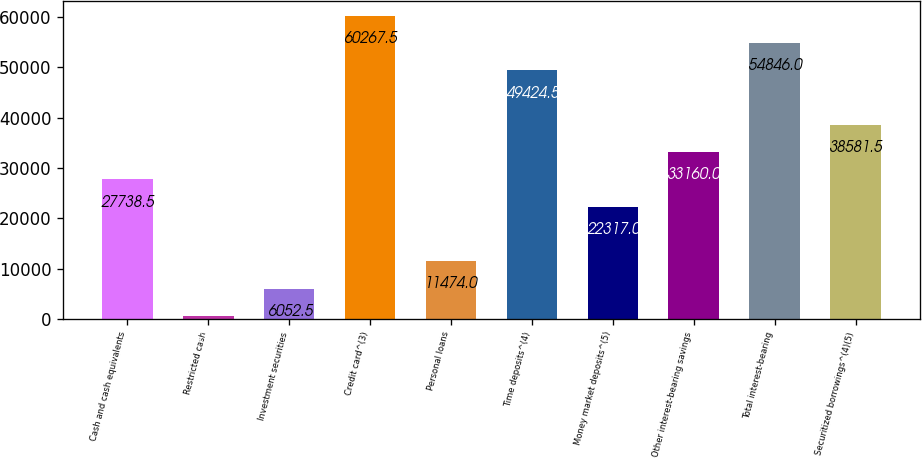Convert chart. <chart><loc_0><loc_0><loc_500><loc_500><bar_chart><fcel>Cash and cash equivalents<fcel>Restricted cash<fcel>Investment securities<fcel>Credit card^(3)<fcel>Personal loans<fcel>Time deposits^(4)<fcel>Money market deposits^(5)<fcel>Other interest-bearing savings<fcel>Total interest-bearing<fcel>Securitized borrowings^(4)(5)<nl><fcel>27738.5<fcel>631<fcel>6052.5<fcel>60267.5<fcel>11474<fcel>49424.5<fcel>22317<fcel>33160<fcel>54846<fcel>38581.5<nl></chart> 